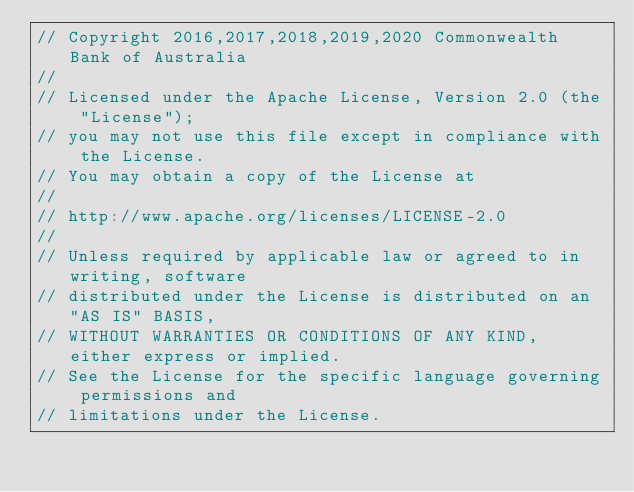Convert code to text. <code><loc_0><loc_0><loc_500><loc_500><_Scala_>// Copyright 2016,2017,2018,2019,2020 Commonwealth Bank of Australia
//
// Licensed under the Apache License, Version 2.0 (the "License");
// you may not use this file except in compliance with the License.
// You may obtain a copy of the License at
//
// http://www.apache.org/licenses/LICENSE-2.0
//
// Unless required by applicable law or agreed to in writing, software
// distributed under the License is distributed on an "AS IS" BASIS,
// WITHOUT WARRANTIES OR CONDITIONS OF ANY KIND, either express or implied.
// See the License for the specific language governing permissions and
// limitations under the License.
</code> 